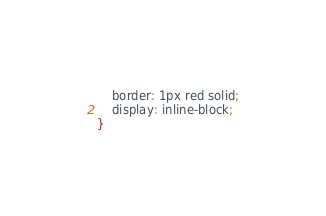<code> <loc_0><loc_0><loc_500><loc_500><_CSS_>    border: 1px red solid;
    display: inline-block;
}</code> 